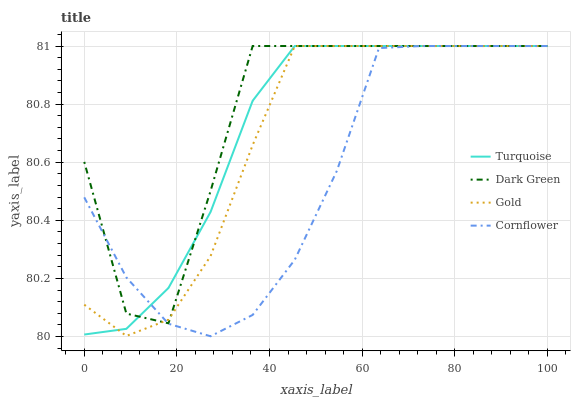Does Cornflower have the minimum area under the curve?
Answer yes or no. Yes. Does Dark Green have the maximum area under the curve?
Answer yes or no. Yes. Does Turquoise have the minimum area under the curve?
Answer yes or no. No. Does Turquoise have the maximum area under the curve?
Answer yes or no. No. Is Turquoise the smoothest?
Answer yes or no. Yes. Is Dark Green the roughest?
Answer yes or no. Yes. Is Gold the smoothest?
Answer yes or no. No. Is Gold the roughest?
Answer yes or no. No. Does Turquoise have the lowest value?
Answer yes or no. No. 